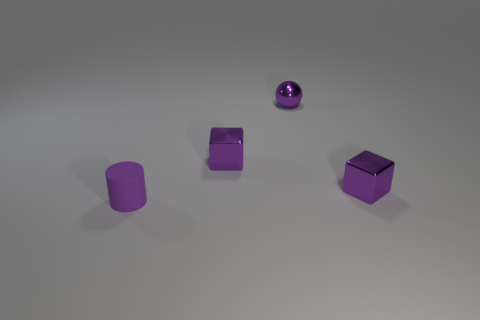What is the size of the sphere that is the same color as the tiny matte thing?
Keep it short and to the point. Small. The purple object in front of the purple block on the right side of the small metallic ball is what shape?
Give a very brief answer. Cylinder. Are there any purple cylinders that are to the right of the tiny purple metallic cube that is in front of the purple shiny object that is on the left side of the small purple ball?
Give a very brief answer. No. What is the color of the ball that is the same size as the purple rubber object?
Ensure brevity in your answer.  Purple. The tiny purple thing that is left of the purple ball and behind the small purple cylinder has what shape?
Keep it short and to the point. Cube. What size is the shiny object behind the metal cube to the left of the small ball?
Provide a succinct answer. Small. What number of matte cylinders have the same color as the ball?
Your response must be concise. 1. How big is the object that is both behind the tiny cylinder and to the left of the purple metal ball?
Ensure brevity in your answer.  Small. What number of other purple objects have the same shape as the purple rubber thing?
Provide a succinct answer. 0. What is the material of the small purple cylinder?
Make the answer very short. Rubber. 